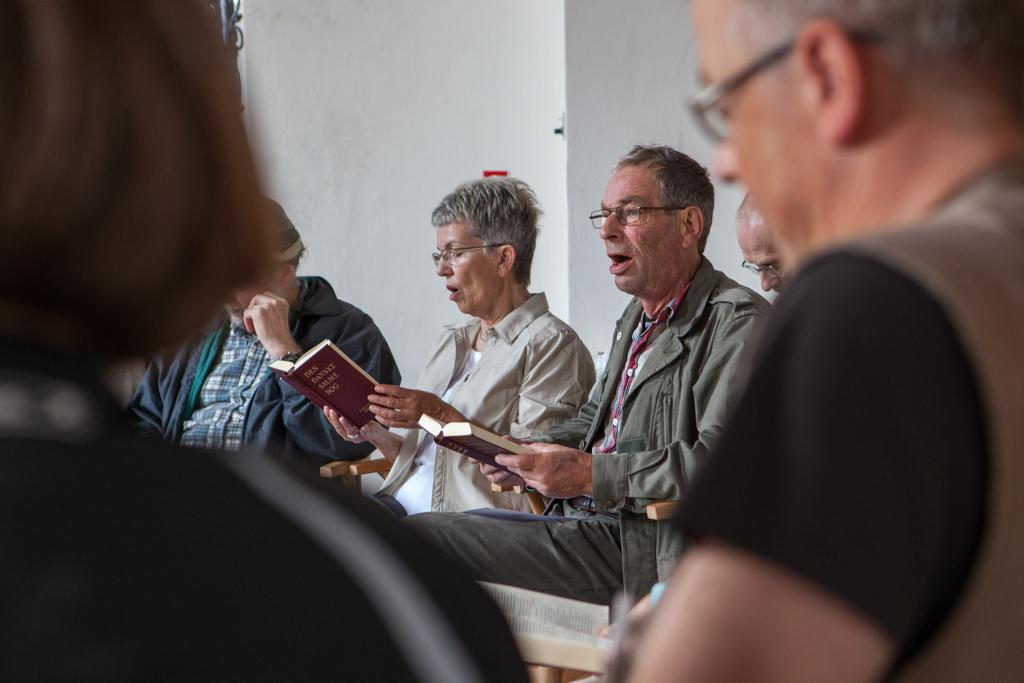What is the general activity of the people in the image? There are many people sitting in the image. Can you describe any specific details about the people? Some of the people are wearing glasses, and some are holding books. What can be seen in the background of the image? There is a wall in the background of the image. What type of screw can be seen holding the animal to the wall in the image? There is no screw or animal present in the image; it features people sitting and holding books. 